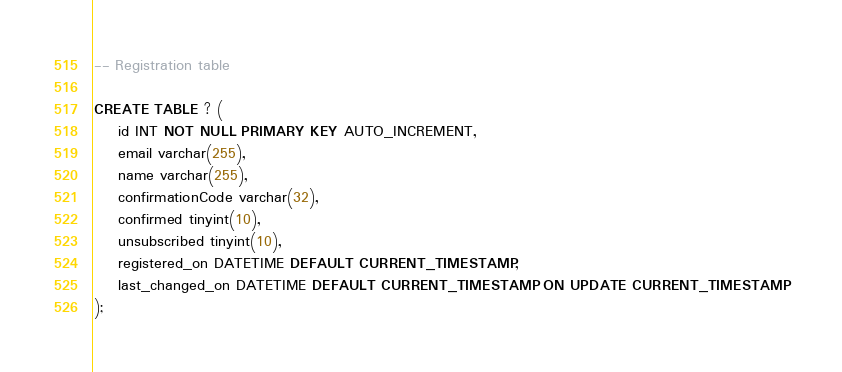Convert code to text. <code><loc_0><loc_0><loc_500><loc_500><_SQL_>-- Registration table

CREATE TABLE ? (
    id INT NOT NULL PRIMARY KEY AUTO_INCREMENT,
    email varchar(255),
    name varchar(255),
    confirmationCode varchar(32),
    confirmed tinyint(10),
    unsubscribed tinyint(10),
    registered_on DATETIME DEFAULT CURRENT_TIMESTAMP,
    last_changed_on DATETIME DEFAULT CURRENT_TIMESTAMP ON UPDATE CURRENT_TIMESTAMP
);</code> 